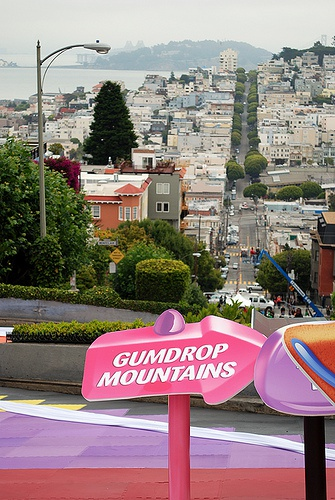Describe the objects in this image and their specific colors. I can see truck in lightgray, darkgray, gray, and black tones, truck in lightgray, black, darkgray, and gray tones, car in lightgray, darkgray, and gray tones, people in lightgray, black, gray, maroon, and red tones, and people in lightgray, black, gray, and darkgray tones in this image. 